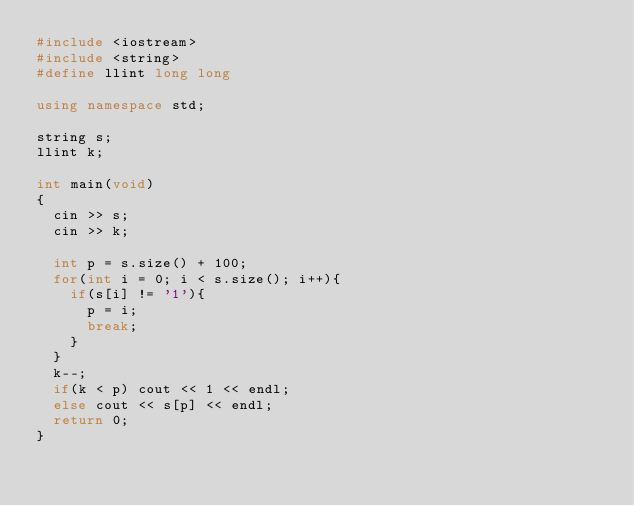Convert code to text. <code><loc_0><loc_0><loc_500><loc_500><_C++_>#include <iostream>
#include <string>
#define llint long long

using namespace std;

string s;
llint k;

int main(void)
{
	cin >> s;
	cin >> k;
	
	int p = s.size() + 100;
	for(int i = 0; i < s.size(); i++){
		if(s[i] != '1'){
			p = i;
			break;
		}
	}
	k--;
	if(k < p) cout << 1 << endl;
	else cout << s[p] << endl;
	return 0;
}</code> 